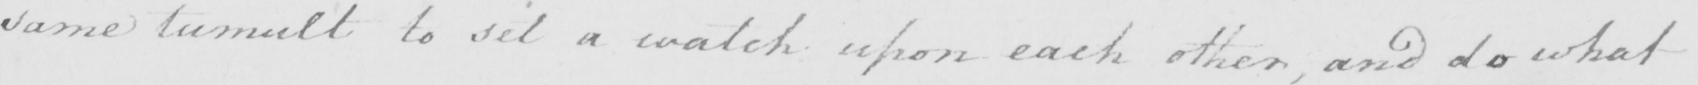What does this handwritten line say? same tumult to sit a watch upon each other, and do what 